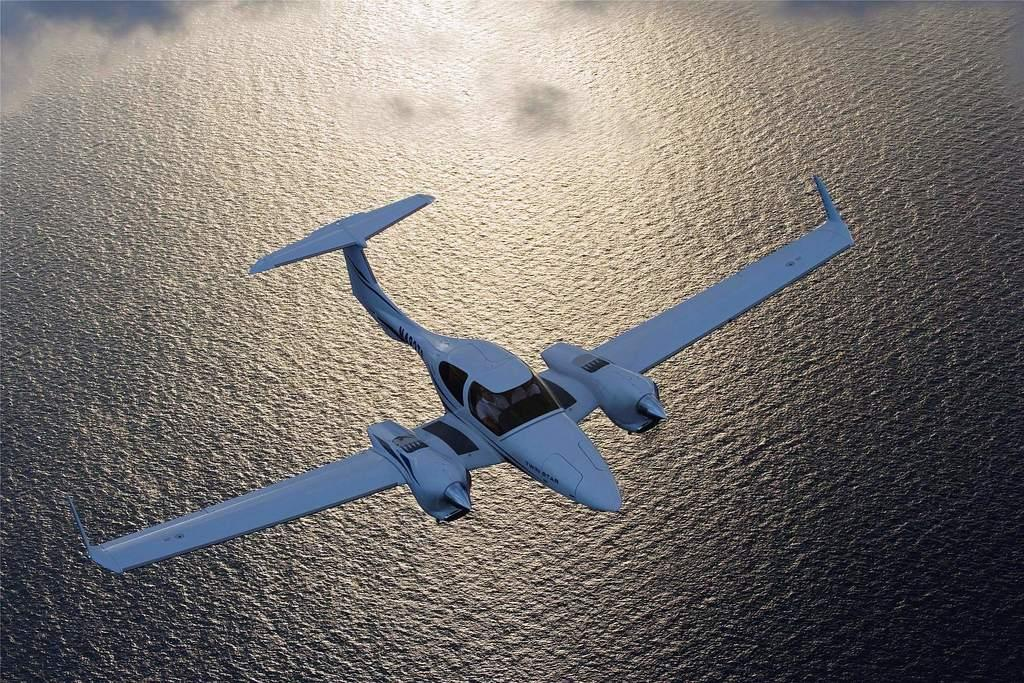What is the main subject of the image? The main subject of the image is an airplane. What is the airplane doing in the image? The airplane is flying in the air. What type of landscape can be seen in the image? There is a sea visible in the image. What type of sound can be heard coming from the chickens in the image? There are no chickens present in the image, so it's not possible to determine what, if any, sounds they might be making. 